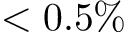Convert formula to latex. <formula><loc_0><loc_0><loc_500><loc_500>< 0 . 5 \%</formula> 